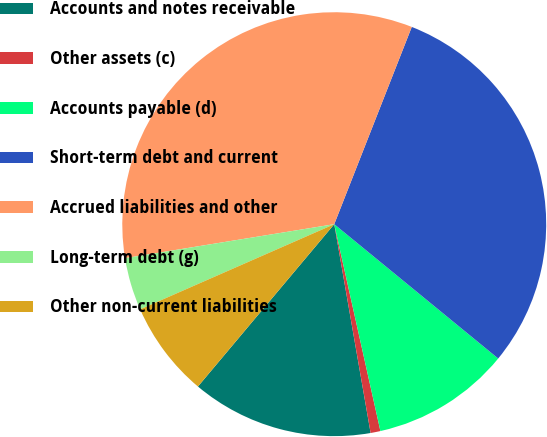Convert chart to OTSL. <chart><loc_0><loc_0><loc_500><loc_500><pie_chart><fcel>Accounts and notes receivable<fcel>Other assets (c)<fcel>Accounts payable (d)<fcel>Short-term debt and current<fcel>Accrued liabilities and other<fcel>Long-term debt (g)<fcel>Other non-current liabilities<nl><fcel>13.86%<fcel>0.75%<fcel>10.58%<fcel>29.96%<fcel>33.52%<fcel>4.02%<fcel>7.3%<nl></chart> 